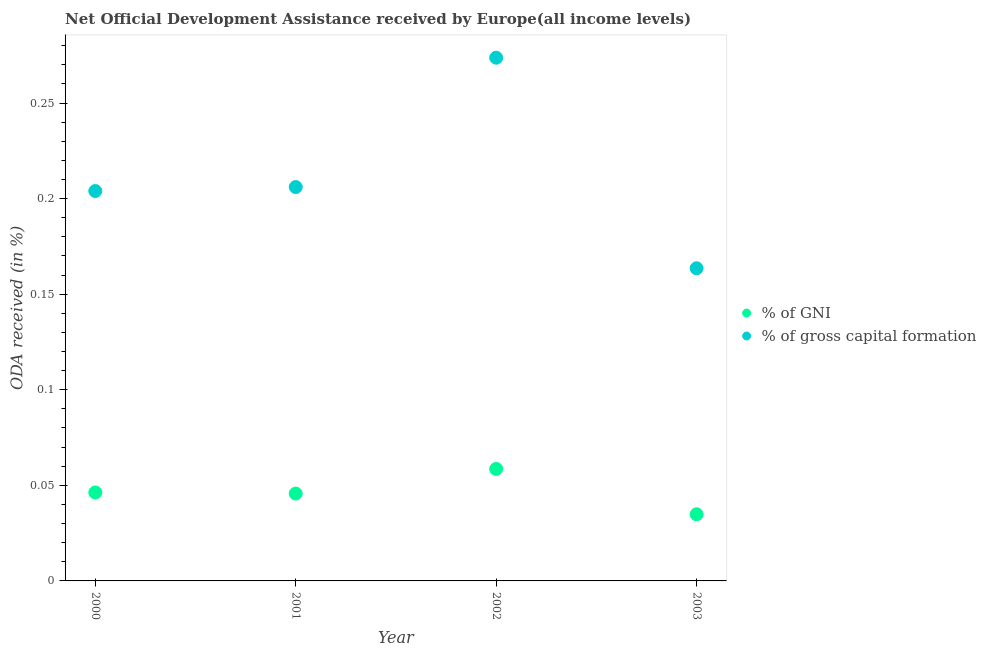What is the oda received as percentage of gross capital formation in 2001?
Make the answer very short. 0.21. Across all years, what is the maximum oda received as percentage of gross capital formation?
Your response must be concise. 0.27. Across all years, what is the minimum oda received as percentage of gross capital formation?
Provide a succinct answer. 0.16. In which year was the oda received as percentage of gross capital formation maximum?
Provide a succinct answer. 2002. What is the total oda received as percentage of gni in the graph?
Your answer should be very brief. 0.19. What is the difference between the oda received as percentage of gni in 2001 and that in 2003?
Make the answer very short. 0.01. What is the difference between the oda received as percentage of gross capital formation in 2001 and the oda received as percentage of gni in 2000?
Provide a succinct answer. 0.16. What is the average oda received as percentage of gni per year?
Your answer should be compact. 0.05. In the year 2001, what is the difference between the oda received as percentage of gni and oda received as percentage of gross capital formation?
Provide a succinct answer. -0.16. In how many years, is the oda received as percentage of gni greater than 0.16000000000000003 %?
Offer a terse response. 0. What is the ratio of the oda received as percentage of gni in 2002 to that in 2003?
Offer a very short reply. 1.68. Is the difference between the oda received as percentage of gni in 2002 and 2003 greater than the difference between the oda received as percentage of gross capital formation in 2002 and 2003?
Give a very brief answer. No. What is the difference between the highest and the second highest oda received as percentage of gni?
Provide a short and direct response. 0.01. What is the difference between the highest and the lowest oda received as percentage of gross capital formation?
Your answer should be compact. 0.11. In how many years, is the oda received as percentage of gni greater than the average oda received as percentage of gni taken over all years?
Make the answer very short. 1. Does the oda received as percentage of gni monotonically increase over the years?
Your answer should be compact. No. Is the oda received as percentage of gross capital formation strictly less than the oda received as percentage of gni over the years?
Your answer should be compact. No. Does the graph contain any zero values?
Offer a terse response. No. How are the legend labels stacked?
Make the answer very short. Vertical. What is the title of the graph?
Give a very brief answer. Net Official Development Assistance received by Europe(all income levels). Does "Food" appear as one of the legend labels in the graph?
Give a very brief answer. No. What is the label or title of the Y-axis?
Offer a very short reply. ODA received (in %). What is the ODA received (in %) of % of GNI in 2000?
Keep it short and to the point. 0.05. What is the ODA received (in %) of % of gross capital formation in 2000?
Give a very brief answer. 0.2. What is the ODA received (in %) of % of GNI in 2001?
Make the answer very short. 0.05. What is the ODA received (in %) of % of gross capital formation in 2001?
Offer a very short reply. 0.21. What is the ODA received (in %) of % of GNI in 2002?
Offer a very short reply. 0.06. What is the ODA received (in %) of % of gross capital formation in 2002?
Give a very brief answer. 0.27. What is the ODA received (in %) of % of GNI in 2003?
Give a very brief answer. 0.03. What is the ODA received (in %) in % of gross capital formation in 2003?
Give a very brief answer. 0.16. Across all years, what is the maximum ODA received (in %) of % of GNI?
Ensure brevity in your answer.  0.06. Across all years, what is the maximum ODA received (in %) in % of gross capital formation?
Your answer should be compact. 0.27. Across all years, what is the minimum ODA received (in %) in % of GNI?
Keep it short and to the point. 0.03. Across all years, what is the minimum ODA received (in %) in % of gross capital formation?
Ensure brevity in your answer.  0.16. What is the total ODA received (in %) in % of GNI in the graph?
Your response must be concise. 0.19. What is the total ODA received (in %) of % of gross capital formation in the graph?
Give a very brief answer. 0.85. What is the difference between the ODA received (in %) of % of GNI in 2000 and that in 2001?
Keep it short and to the point. 0. What is the difference between the ODA received (in %) of % of gross capital formation in 2000 and that in 2001?
Your answer should be very brief. -0. What is the difference between the ODA received (in %) of % of GNI in 2000 and that in 2002?
Your answer should be compact. -0.01. What is the difference between the ODA received (in %) in % of gross capital formation in 2000 and that in 2002?
Provide a succinct answer. -0.07. What is the difference between the ODA received (in %) of % of GNI in 2000 and that in 2003?
Your answer should be very brief. 0.01. What is the difference between the ODA received (in %) of % of gross capital formation in 2000 and that in 2003?
Your answer should be very brief. 0.04. What is the difference between the ODA received (in %) in % of GNI in 2001 and that in 2002?
Your answer should be very brief. -0.01. What is the difference between the ODA received (in %) in % of gross capital formation in 2001 and that in 2002?
Your answer should be compact. -0.07. What is the difference between the ODA received (in %) in % of GNI in 2001 and that in 2003?
Your answer should be compact. 0.01. What is the difference between the ODA received (in %) of % of gross capital formation in 2001 and that in 2003?
Keep it short and to the point. 0.04. What is the difference between the ODA received (in %) of % of GNI in 2002 and that in 2003?
Give a very brief answer. 0.02. What is the difference between the ODA received (in %) of % of gross capital formation in 2002 and that in 2003?
Give a very brief answer. 0.11. What is the difference between the ODA received (in %) of % of GNI in 2000 and the ODA received (in %) of % of gross capital formation in 2001?
Offer a very short reply. -0.16. What is the difference between the ODA received (in %) of % of GNI in 2000 and the ODA received (in %) of % of gross capital formation in 2002?
Your answer should be compact. -0.23. What is the difference between the ODA received (in %) in % of GNI in 2000 and the ODA received (in %) in % of gross capital formation in 2003?
Give a very brief answer. -0.12. What is the difference between the ODA received (in %) of % of GNI in 2001 and the ODA received (in %) of % of gross capital formation in 2002?
Offer a terse response. -0.23. What is the difference between the ODA received (in %) in % of GNI in 2001 and the ODA received (in %) in % of gross capital formation in 2003?
Your response must be concise. -0.12. What is the difference between the ODA received (in %) of % of GNI in 2002 and the ODA received (in %) of % of gross capital formation in 2003?
Your response must be concise. -0.1. What is the average ODA received (in %) in % of GNI per year?
Provide a succinct answer. 0.05. What is the average ODA received (in %) in % of gross capital formation per year?
Offer a terse response. 0.21. In the year 2000, what is the difference between the ODA received (in %) in % of GNI and ODA received (in %) in % of gross capital formation?
Offer a terse response. -0.16. In the year 2001, what is the difference between the ODA received (in %) in % of GNI and ODA received (in %) in % of gross capital formation?
Your answer should be very brief. -0.16. In the year 2002, what is the difference between the ODA received (in %) in % of GNI and ODA received (in %) in % of gross capital formation?
Offer a very short reply. -0.22. In the year 2003, what is the difference between the ODA received (in %) of % of GNI and ODA received (in %) of % of gross capital formation?
Provide a short and direct response. -0.13. What is the ratio of the ODA received (in %) in % of GNI in 2000 to that in 2001?
Make the answer very short. 1.01. What is the ratio of the ODA received (in %) of % of GNI in 2000 to that in 2002?
Give a very brief answer. 0.79. What is the ratio of the ODA received (in %) in % of gross capital formation in 2000 to that in 2002?
Your answer should be very brief. 0.75. What is the ratio of the ODA received (in %) in % of GNI in 2000 to that in 2003?
Ensure brevity in your answer.  1.33. What is the ratio of the ODA received (in %) in % of gross capital formation in 2000 to that in 2003?
Give a very brief answer. 1.25. What is the ratio of the ODA received (in %) of % of GNI in 2001 to that in 2002?
Give a very brief answer. 0.78. What is the ratio of the ODA received (in %) in % of gross capital formation in 2001 to that in 2002?
Give a very brief answer. 0.75. What is the ratio of the ODA received (in %) of % of GNI in 2001 to that in 2003?
Your answer should be compact. 1.31. What is the ratio of the ODA received (in %) in % of gross capital formation in 2001 to that in 2003?
Offer a very short reply. 1.26. What is the ratio of the ODA received (in %) in % of GNI in 2002 to that in 2003?
Your answer should be compact. 1.68. What is the ratio of the ODA received (in %) of % of gross capital formation in 2002 to that in 2003?
Offer a very short reply. 1.67. What is the difference between the highest and the second highest ODA received (in %) in % of GNI?
Offer a very short reply. 0.01. What is the difference between the highest and the second highest ODA received (in %) in % of gross capital formation?
Keep it short and to the point. 0.07. What is the difference between the highest and the lowest ODA received (in %) of % of GNI?
Your response must be concise. 0.02. What is the difference between the highest and the lowest ODA received (in %) of % of gross capital formation?
Provide a short and direct response. 0.11. 